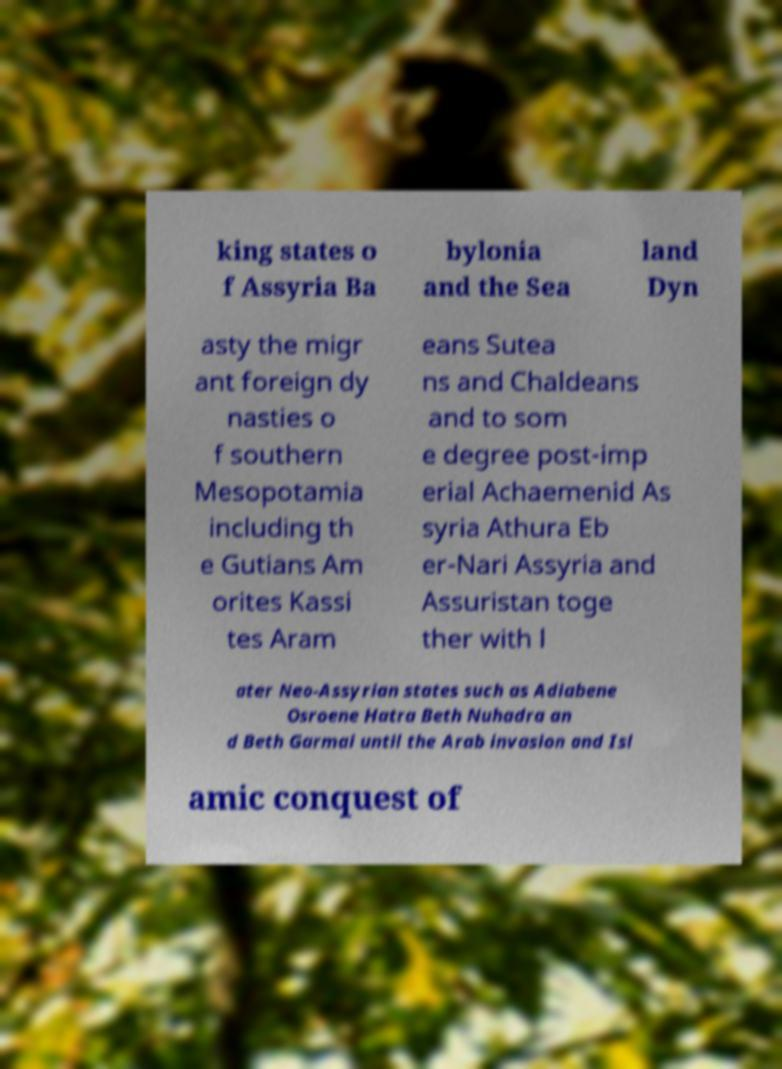There's text embedded in this image that I need extracted. Can you transcribe it verbatim? king states o f Assyria Ba bylonia and the Sea land Dyn asty the migr ant foreign dy nasties o f southern Mesopotamia including th e Gutians Am orites Kassi tes Aram eans Sutea ns and Chaldeans and to som e degree post-imp erial Achaemenid As syria Athura Eb er-Nari Assyria and Assuristan toge ther with l ater Neo-Assyrian states such as Adiabene Osroene Hatra Beth Nuhadra an d Beth Garmai until the Arab invasion and Isl amic conquest of 